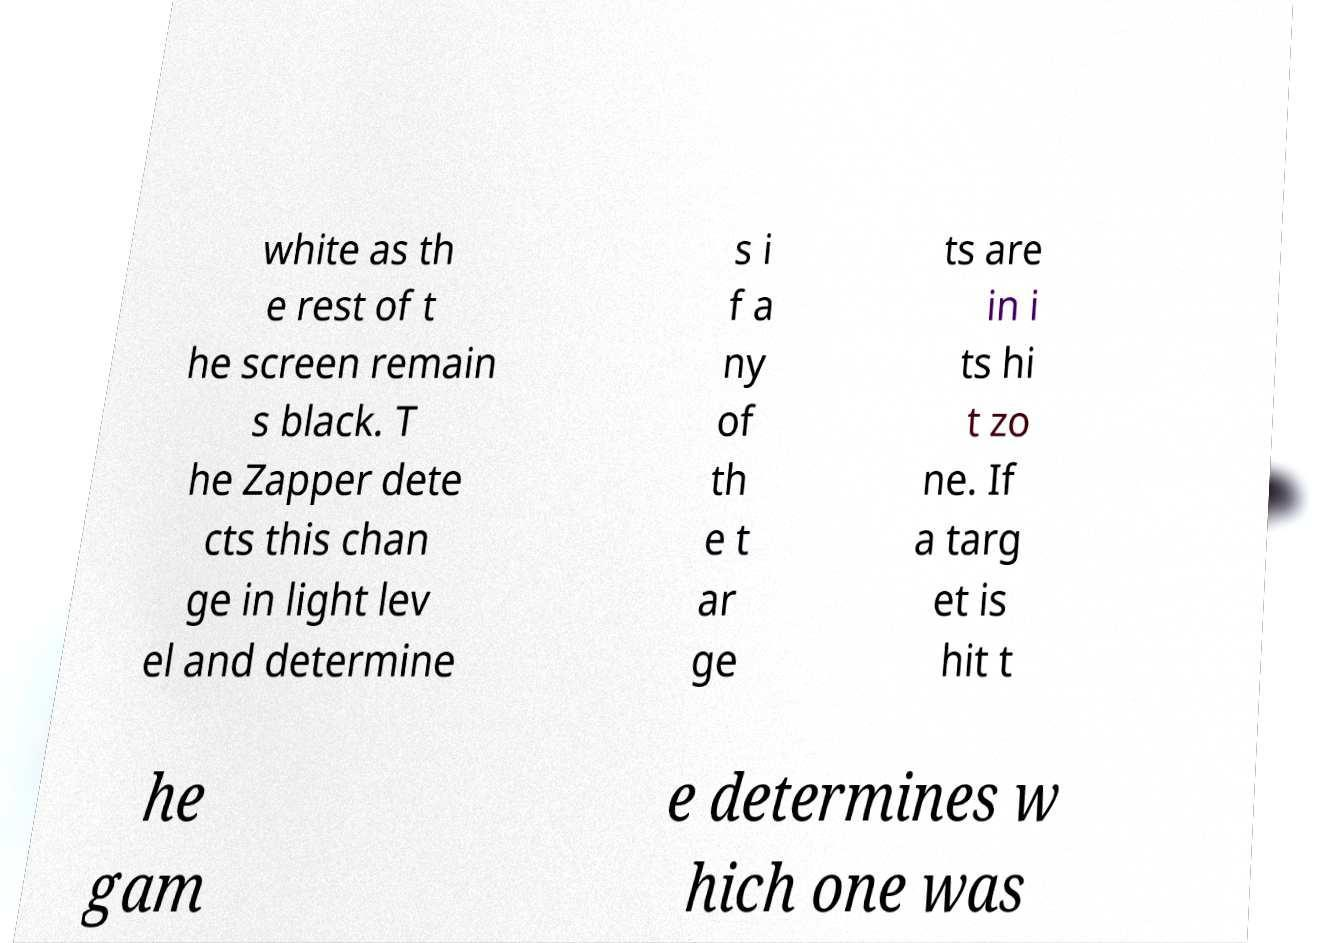Please identify and transcribe the text found in this image. white as th e rest of t he screen remain s black. T he Zapper dete cts this chan ge in light lev el and determine s i f a ny of th e t ar ge ts are in i ts hi t zo ne. If a targ et is hit t he gam e determines w hich one was 